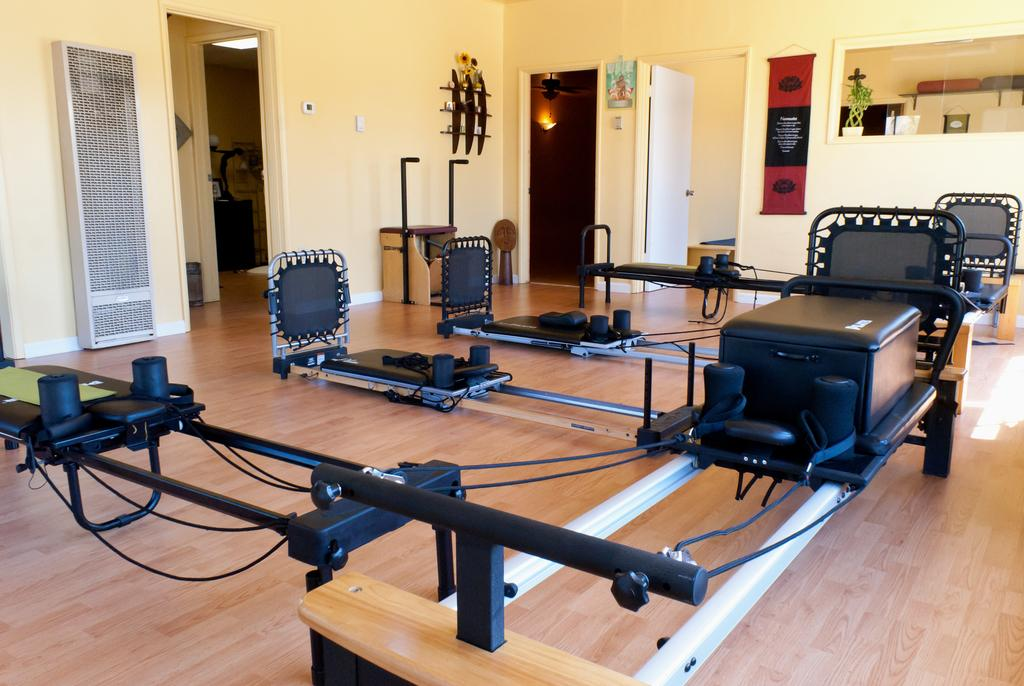What type of equipment can be seen in the image? There is gym equipment in the image. What can be seen on the walls in the background? There are things hanging on the walls in the background. What piece of furniture is present in the image? There is a table in the image. How many distinct spaces are visible in the image? There are rooms visible in the image. What feature allows for access between different spaces? There are doors visible in the image. What type of meat is being prepared on the ship in the image? There is no meat or ship present in the image; it features gym equipment, walls with items hanging, a table, rooms, and doors. 